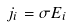Convert formula to latex. <formula><loc_0><loc_0><loc_500><loc_500>j _ { i } = \sigma E _ { i }</formula> 